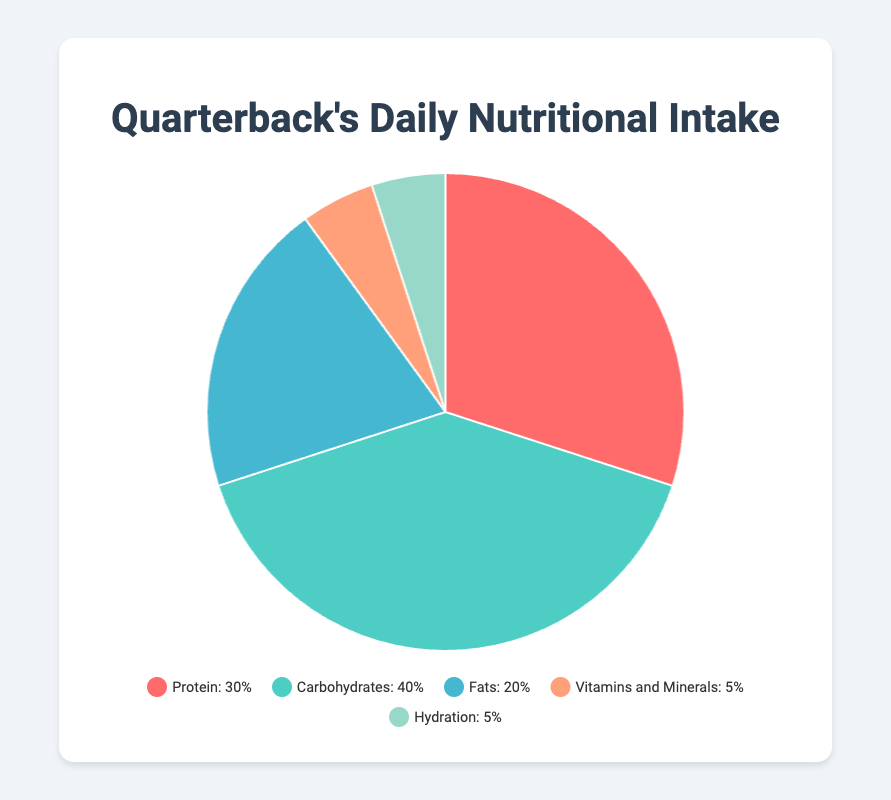What percentage of the daily intake is attributed to both Protein and Carbohydrates combined? Sum the percentages for Protein and Carbohydrates: 30% (Protein) + 40% (Carbohydrates) = 70%
Answer: 70% Which nutrient category occupies the largest portion of the daily intake? Compare the percentages for all categories: Protein (30%), Carbohydrates (40%), Fats (20%), Vitamins and Minerals (5%), Hydration (5%). The largest value is 40% for Carbohydrates
Answer: Carbohydrates What is the difference in percentage between Fats and Vitamins and Minerals? Subtract the percentage of Vitamins and Minerals from Fats: 20% (Fats) - 5% (Vitamins and Minerals) = 15%
Answer: 15% Which nutrients together make up 10% of the daily intake? Sum the percentages of Vitamins and Minerals and Hydration: 5% (Vitamins and Minerals) + 5% (Hydration) = 10%
Answer: Vitamins and Minerals, Hydration What color represents the Protein in the pie chart? The color assigned to Protein slice in the pie chart is red
Answer: Red Do Carbohydrates represent more than twice the percentage of Fats in the daily intake? Compare the percentage of Carbohydrates and twice the percentage of Fats: 40% (Carbohydrates) and 2 * 20% (Fats) = 40%. They are equal
Answer: No Between Protein and Fats, which has the smaller percentage and by how much? Compare their percentages: Protein (30%) and Fats (20%). Subtract the smaller from the larger: 30% - 20% = 10%
Answer: Fats, by 10% What portion of the daily intake is covered by non-macronutrients (Vitamins and Minerals, Hydration)? Sum the percentages of Vitamins and Minerals and Hydration: 5% (Vitamins and Minerals) + 5% (Hydration) = 10%
Answer: 10% What is the combined percentage of the top three nutritional categories? Sum the percentages of Protein, Carbohydrates, and Fats: 30% (Protein) + 40% (Carbohydrates) + 20% (Fats) = 90%
Answer: 90% Are the segments for Vitamins and Minerals and Hydration equivalent in size? The percentages for both categories are equal at 5%
Answer: Yes 